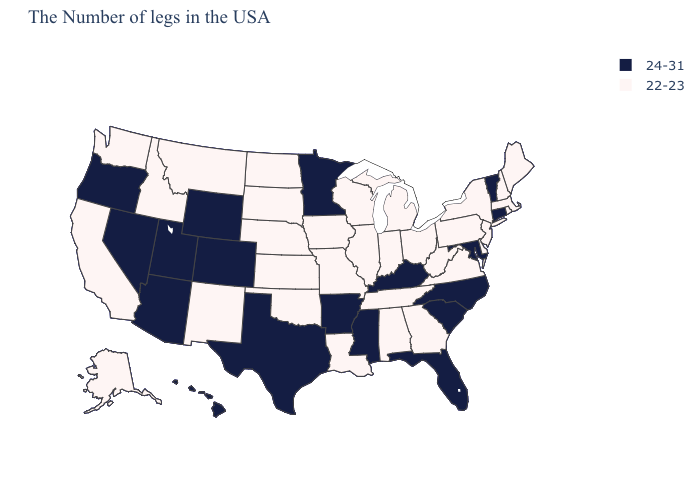What is the lowest value in states that border Utah?
Short answer required. 22-23. What is the value of Missouri?
Short answer required. 22-23. Among the states that border Connecticut , which have the lowest value?
Give a very brief answer. Massachusetts, Rhode Island, New York. Does Minnesota have the highest value in the MidWest?
Write a very short answer. Yes. Among the states that border Florida , which have the highest value?
Concise answer only. Georgia, Alabama. Which states have the highest value in the USA?
Quick response, please. Vermont, Connecticut, Maryland, North Carolina, South Carolina, Florida, Kentucky, Mississippi, Arkansas, Minnesota, Texas, Wyoming, Colorado, Utah, Arizona, Nevada, Oregon, Hawaii. Does the map have missing data?
Concise answer only. No. Which states have the lowest value in the USA?
Keep it brief. Maine, Massachusetts, Rhode Island, New Hampshire, New York, New Jersey, Delaware, Pennsylvania, Virginia, West Virginia, Ohio, Georgia, Michigan, Indiana, Alabama, Tennessee, Wisconsin, Illinois, Louisiana, Missouri, Iowa, Kansas, Nebraska, Oklahoma, South Dakota, North Dakota, New Mexico, Montana, Idaho, California, Washington, Alaska. What is the value of Pennsylvania?
Answer briefly. 22-23. What is the highest value in the USA?
Keep it brief. 24-31. Name the states that have a value in the range 24-31?
Short answer required. Vermont, Connecticut, Maryland, North Carolina, South Carolina, Florida, Kentucky, Mississippi, Arkansas, Minnesota, Texas, Wyoming, Colorado, Utah, Arizona, Nevada, Oregon, Hawaii. What is the value of Arkansas?
Keep it brief. 24-31. Does Indiana have the lowest value in the USA?
Write a very short answer. Yes. What is the value of Texas?
Be succinct. 24-31. Is the legend a continuous bar?
Short answer required. No. 